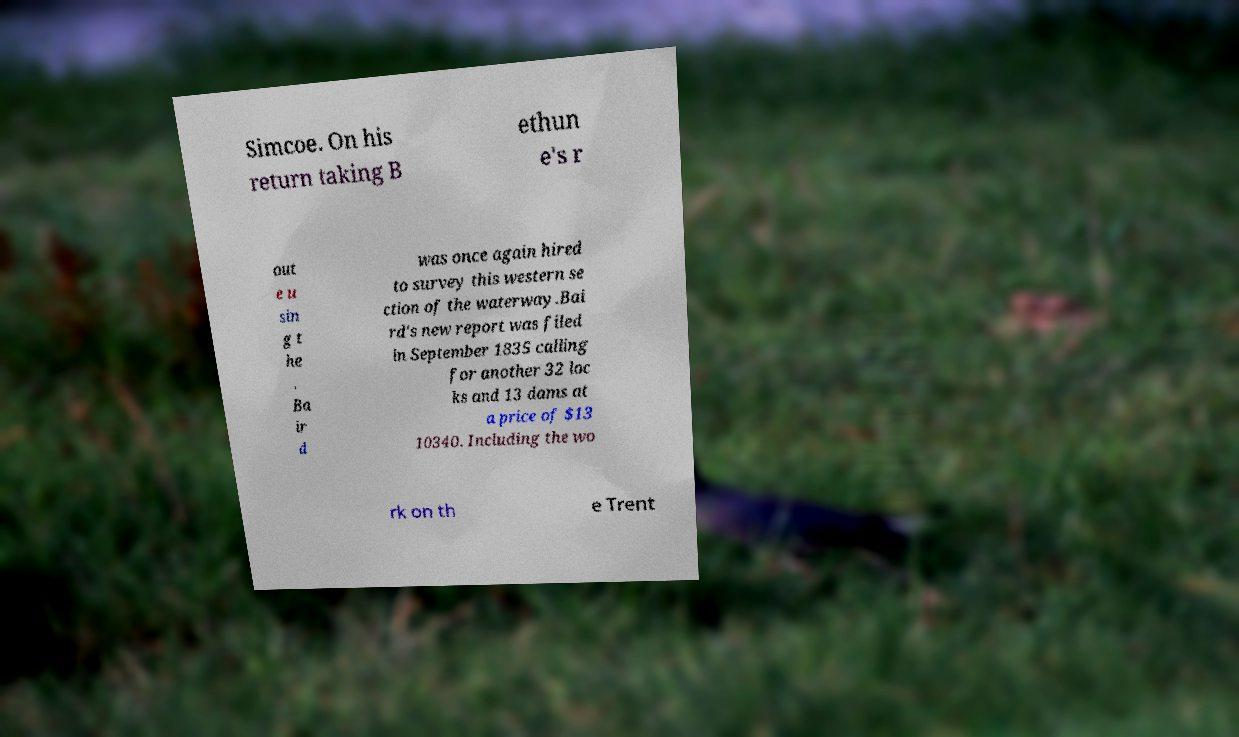I need the written content from this picture converted into text. Can you do that? Simcoe. On his return taking B ethun e's r out e u sin g t he . Ba ir d was once again hired to survey this western se ction of the waterway.Bai rd's new report was filed in September 1835 calling for another 32 loc ks and 13 dams at a price of $13 10340. Including the wo rk on th e Trent 